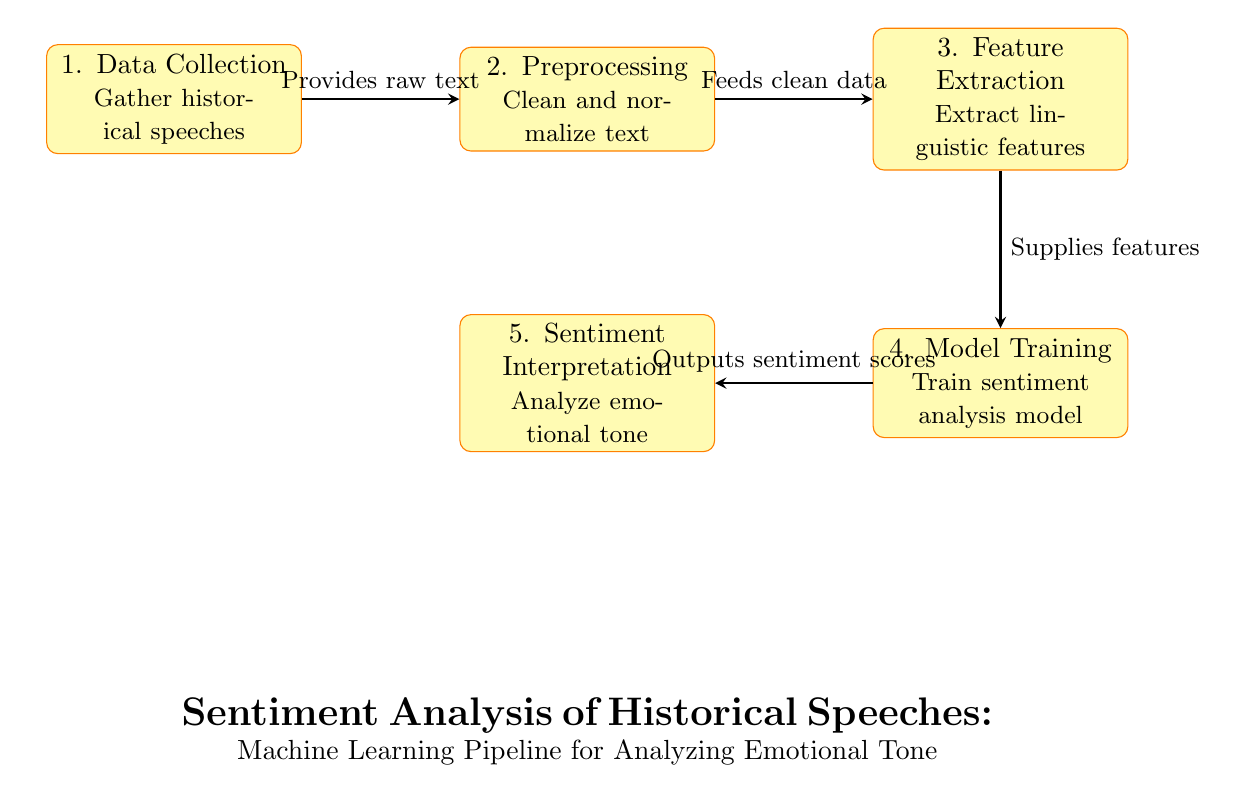What is the first step in the pipeline? The first step in the pipeline is "Data Collection," which involves gathering historical speeches as the initial input for further processing.
Answer: Data Collection How many processes are in the diagram? The diagram contains five distinct processes: Data Collection, Preprocessing, Feature Extraction, Model Training, and Sentiment Interpretation, which describe different stages in analyzing historical speeches.
Answer: Five Which process outputs sentiment scores? The process that outputs sentiment scores is "Model Training," as indicated by the arrow directing the results to the "Sentiment Interpretation" node.
Answer: Model Training What does the arrow from Preprocessing to Feature Extraction indicate? The arrow from Preprocessing to Feature Extraction indicates that the output of the Preprocessing step, which provides clean data, is used as the input for the Feature Extraction step.
Answer: Feeds clean data What is extracted in the Feature Extraction step? In the Feature Extraction step, linguistic features are extracted from the cleaned text data, facilitating model training for sentiment analysis.
Answer: Linguistic features How does Sentiment Interpretation relate to Model Training? Sentiment Interpretation relies on the outputs generated by Model Training, which provides sentiment scores that are then analyzed for emotional tone.
Answer: Outputs sentiment scores What happens after Data Collection? After Data Collection, the next step is Preprocessing, which cleans and normalizes the text gathered from historical speeches.
Answer: Preprocessing Which process follows Feature Extraction? The process that follows Feature Extraction is Model Training, where the extracted features are used to train the sentiment analysis model.
Answer: Model Training What is the significance of the arrow leading from Model Training to Sentiment Interpretation? The arrow indicates the flow of results, showing that the sentiment scores produced in Model Training are interpreted in the subsequent step, Sentiment Interpretation, to assess emotional tone.
Answer: Outputs sentiment scores 